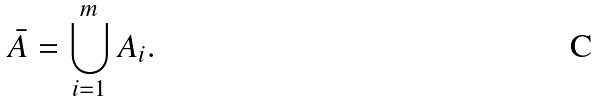Convert formula to latex. <formula><loc_0><loc_0><loc_500><loc_500>\bar { A } = \bigcup _ { i = 1 } ^ { m } { A _ { i } } .</formula> 